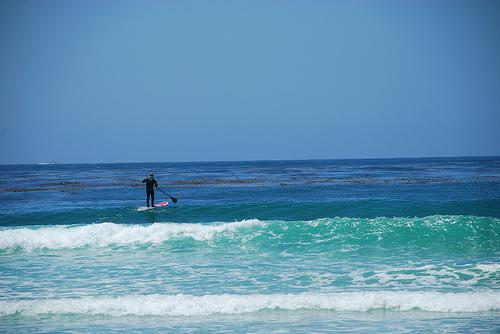Question: how many men can be seen?
Choices:
A. Two.
B. One.
C. Three.
D. Four.
Answer with the letter. Answer: B Question: what is in the water?
Choices:
A. A surfer.
B. A shark.
C. A whale.
D. A boat.
Answer with the letter. Answer: A Question: where is the paddle?
Choices:
A. The man is holding it.
B. In the boat.
C. In the water.
D. The woman has it.
Answer with the letter. Answer: A Question: who is with him?
Choices:
A. His wife.
B. His son.
C. Nobody.
D. His daughter.
Answer with the letter. Answer: C 